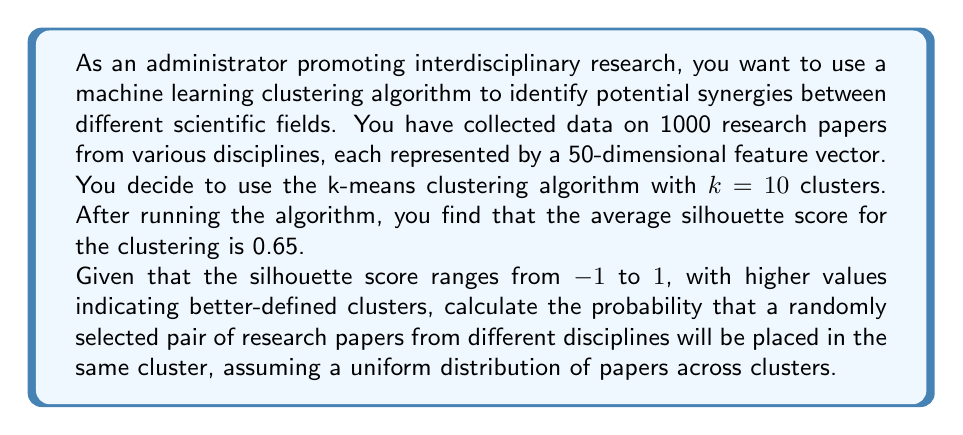Could you help me with this problem? To solve this problem, we need to follow these steps:

1. Understand the given information:
   - We have 1000 research papers
   - The k-means algorithm was used with $k=10$ clusters
   - The average silhouette score is 0.65

2. Interpret the silhouette score:
   The silhouette score of 0.65 indicates a relatively good clustering, suggesting that papers within the same cluster are likely to be more similar to each other than to papers in other clusters.

3. Assume uniform distribution of papers across clusters:
   With 1000 papers and 10 clusters, we can assume each cluster contains 100 papers on average.

4. Calculate the probability of selecting two papers from the same cluster:
   - Probability of selecting the first paper from any cluster: $1$
   - Probability of selecting the second paper from the same cluster: $\frac{99}{999}$
   
   $P(\text{same cluster}) = 1 \cdot \frac{99}{999} = \frac{99}{999} \approx 0.0991$

5. Calculate the probability of selecting two papers from different clusters:
   $P(\text{different clusters}) = 1 - P(\text{same cluster}) = 1 - \frac{99}{999} = \frac{900}{999} \approx 0.9009$

Therefore, the probability that a randomly selected pair of research papers from different disciplines will be placed in the same cluster is approximately 0.0991 or 9.91%.
Answer: The probability that a randomly selected pair of research papers from different disciplines will be placed in the same cluster is approximately 0.0991 or 9.91%. 